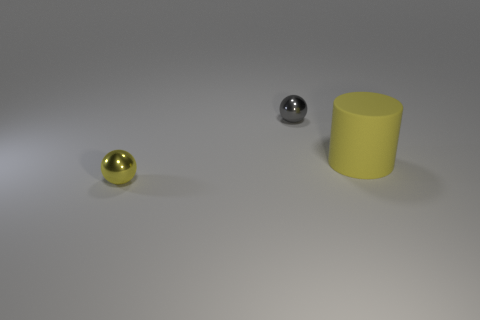There is a thing on the left side of the gray ball; is it the same color as the big cylinder?
Your answer should be compact. Yes. What shape is the large matte object right of the yellow object to the left of the tiny sphere that is behind the large yellow cylinder?
Provide a succinct answer. Cylinder. There is a yellow cylinder; is it the same size as the metal object that is behind the tiny yellow object?
Your answer should be very brief. No. Are there any shiny things of the same size as the gray sphere?
Your response must be concise. Yes. How many other objects are the same material as the tiny yellow thing?
Your response must be concise. 1. The object that is both in front of the tiny gray ball and to the left of the yellow matte cylinder is what color?
Provide a succinct answer. Yellow. Do the tiny object in front of the small gray thing and the yellow thing that is on the right side of the gray metal ball have the same material?
Ensure brevity in your answer.  No. Do the metallic thing to the right of the yellow ball and the large yellow cylinder have the same size?
Make the answer very short. No. Is the color of the big cylinder the same as the small shiny ball in front of the gray metallic object?
Your response must be concise. Yes. There is another thing that is the same color as the large object; what shape is it?
Your response must be concise. Sphere. 